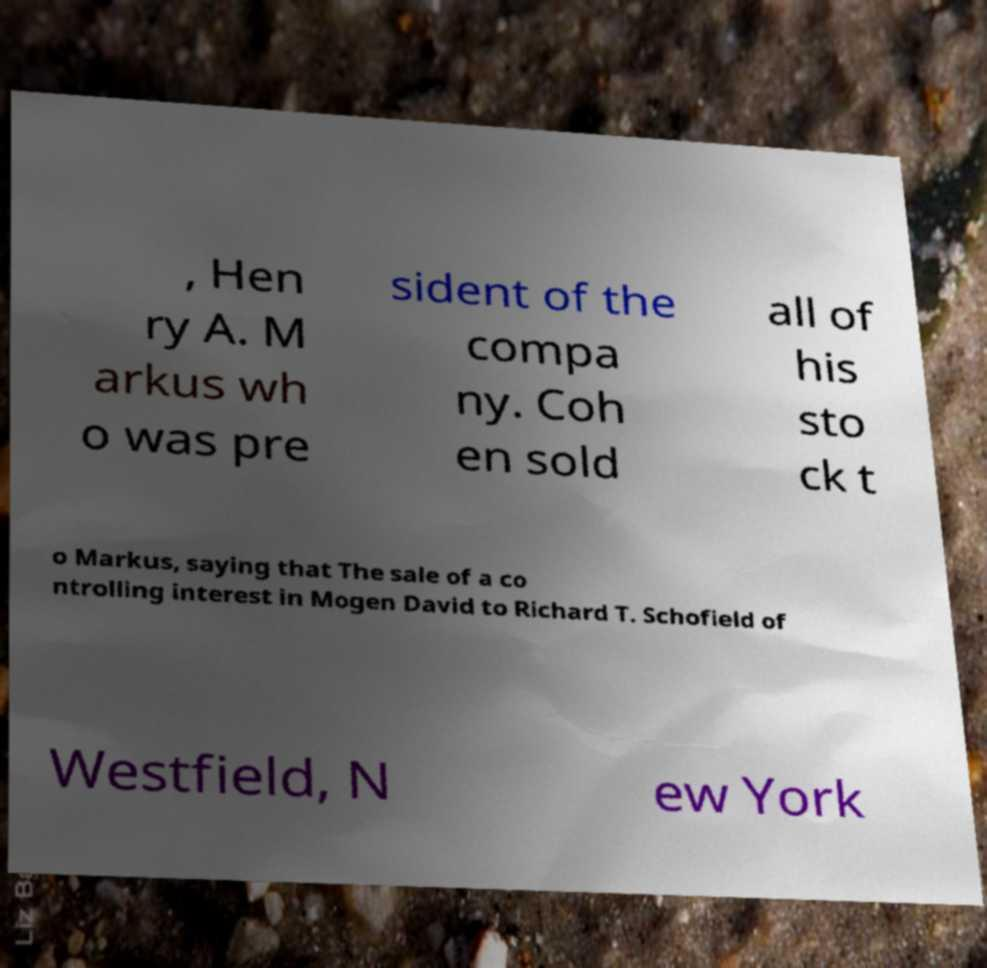Could you assist in decoding the text presented in this image and type it out clearly? , Hen ry A. M arkus wh o was pre sident of the compa ny. Coh en sold all of his sto ck t o Markus, saying that The sale of a co ntrolling interest in Mogen David to Richard T. Schofield of Westfield, N ew York 